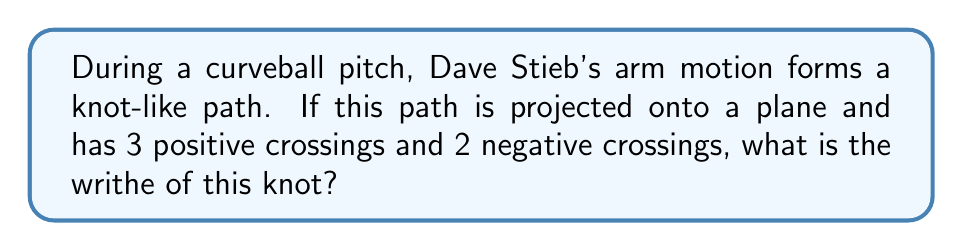Solve this math problem. To calculate the writhe of a knot, we need to follow these steps:

1. Understand the concept of writhe:
   The writhe is a measure of the coiling of a knot when projected onto a plane.

2. Identify crossings:
   In this case, we have 3 positive crossings and 2 negative crossings.

3. Calculate the writhe:
   The writhe is calculated by subtracting the number of negative crossings from the number of positive crossings.

   Let $p$ be the number of positive crossings and $n$ be the number of negative crossings.
   
   The formula for writhe $w$ is:

   $$w = p - n$$

4. Substitute the values:
   $p = 3$ (positive crossings)
   $n = 2$ (negative crossings)

   $$w = 3 - 2$$

5. Perform the calculation:
   $$w = 1$$

Therefore, the writhe of the knot formed by Dave Stieb's arm motion during the curveball throw is 1.
Answer: 1 